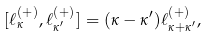<formula> <loc_0><loc_0><loc_500><loc_500>[ \ell _ { \kappa } ^ { ( + ) } , \ell _ { \kappa ^ { \prime } } ^ { ( + ) } ] = ( \kappa - \kappa ^ { \prime } ) \ell _ { \kappa + \kappa ^ { \prime } } ^ { ( + ) } ,</formula> 